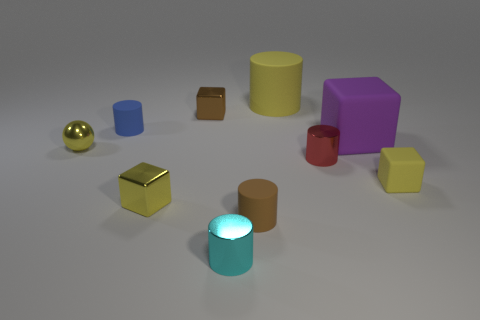Is the number of balls less than the number of yellow matte things?
Provide a succinct answer. Yes. There is a matte block that is to the left of the tiny yellow matte block; is it the same size as the yellow rubber object that is behind the tiny red shiny cylinder?
Your response must be concise. Yes. What number of yellow objects are tiny shiny cubes or cylinders?
Ensure brevity in your answer.  2. What is the size of the matte cylinder that is the same color as the small shiny ball?
Give a very brief answer. Large. Are there more cylinders than tiny yellow balls?
Keep it short and to the point. Yes. Is the tiny rubber block the same color as the large block?
Offer a very short reply. No. What number of things are small blue rubber things or tiny metal objects to the right of the cyan shiny cylinder?
Give a very brief answer. 2. What number of other objects are the same shape as the tiny red thing?
Offer a terse response. 4. Is the number of large blocks to the left of the yellow ball less than the number of metallic objects to the right of the large cylinder?
Your answer should be very brief. Yes. What shape is the brown object that is made of the same material as the purple block?
Give a very brief answer. Cylinder. 